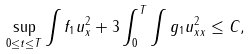Convert formula to latex. <formula><loc_0><loc_0><loc_500><loc_500>\sup _ { 0 \leq t \leq T } \int f _ { 1 } u _ { x } ^ { 2 } + 3 \int _ { 0 } ^ { T } \int g _ { 1 } u _ { x x } ^ { 2 } \leq C ,</formula> 